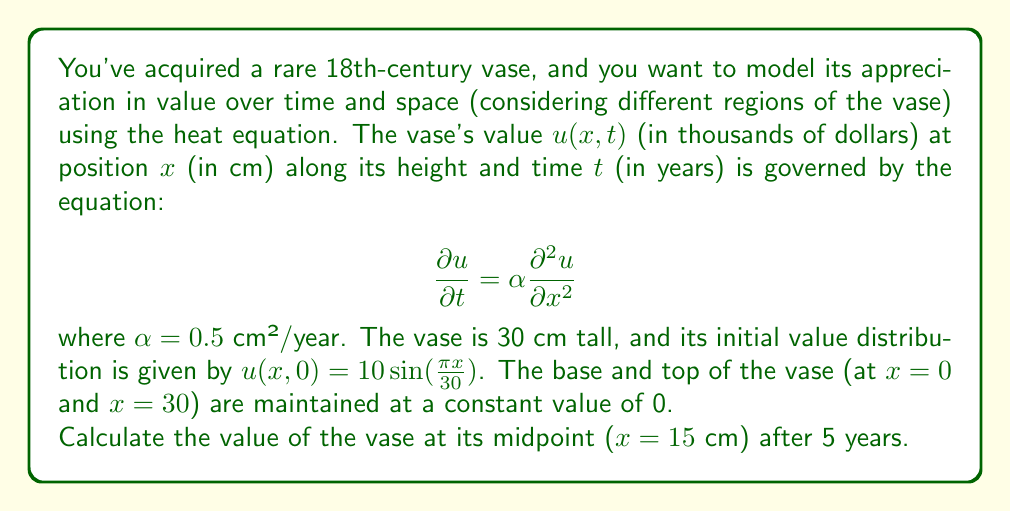Can you answer this question? To solve this problem, we need to use the separation of variables method for the heat equation with the given initial and boundary conditions.

1) First, let's write the general solution for the heat equation:

   $$u(x,t) = \sum_{n=1}^{\infty} B_n \sin(\frac{n\pi x}{L}) e^{-\alpha (\frac{n\pi}{L})^2 t}$$

   where $L$ is the length of the vase (30 cm).

2) The initial condition is $u(x,0) = 10 \sin(\frac{\pi x}{30})$. This matches the first term of our series (when $n=1$), so we have:

   $B_1 = 10$ and $B_n = 0$ for $n > 1$

3) Therefore, our solution simplifies to:

   $$u(x,t) = 10 \sin(\frac{\pi x}{30}) e^{-\alpha (\frac{\pi}{30})^2 t}$$

4) Now, we need to evaluate this at $x = 15$ cm and $t = 5$ years:

   $$u(15,5) = 10 \sin(\frac{\pi 15}{30}) e^{-0.5 (\frac{\pi}{30})^2 5}$$

5) Simplify:
   
   $$u(15,5) = 10 \sin(\frac{\pi}{2}) e^{-0.5 (\frac{\pi}{30})^2 5}$$
   
   $$= 10 \cdot 1 \cdot e^{-0.5 (\frac{\pi^2}{1800}) 5}$$
   
   $$= 10 e^{-\frac{5\pi^2}{3600}}$$

6) Calculate the final value:

   $$u(15,5) \approx 8.6452$$

Therefore, the value of the vase at its midpoint after 5 years is approximately 8.6452 thousand dollars, or $8,645.20.
Answer: $8,645.20 